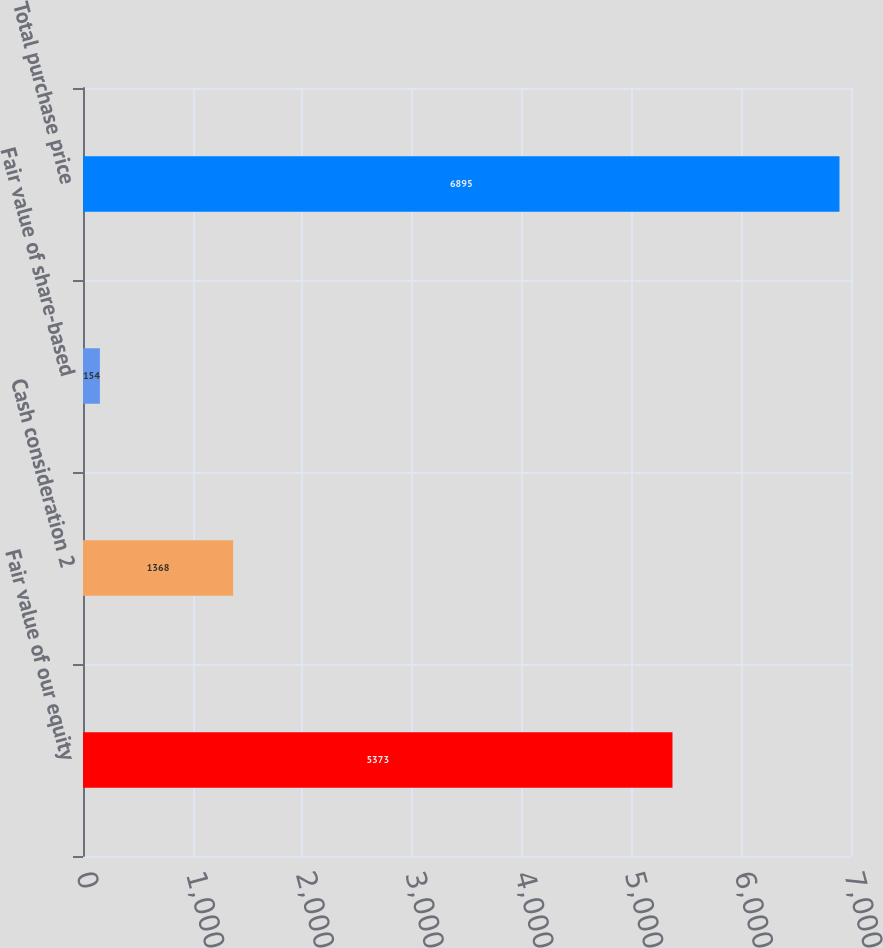Convert chart to OTSL. <chart><loc_0><loc_0><loc_500><loc_500><bar_chart><fcel>Fair value of our equity<fcel>Cash consideration 2<fcel>Fair value of share-based<fcel>Total purchase price<nl><fcel>5373<fcel>1368<fcel>154<fcel>6895<nl></chart> 